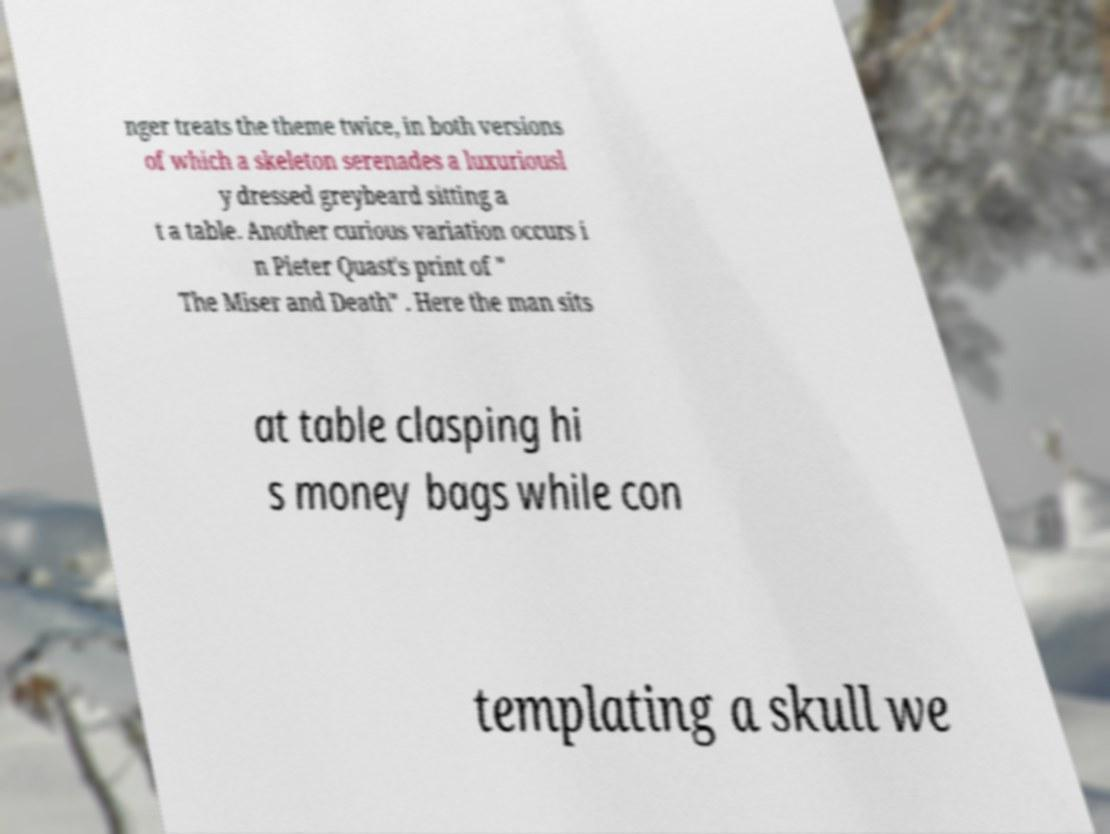There's text embedded in this image that I need extracted. Can you transcribe it verbatim? nger treats the theme twice, in both versions of which a skeleton serenades a luxuriousl y dressed greybeard sitting a t a table. Another curious variation occurs i n Pieter Quast's print of " The Miser and Death" . Here the man sits at table clasping hi s money bags while con templating a skull we 